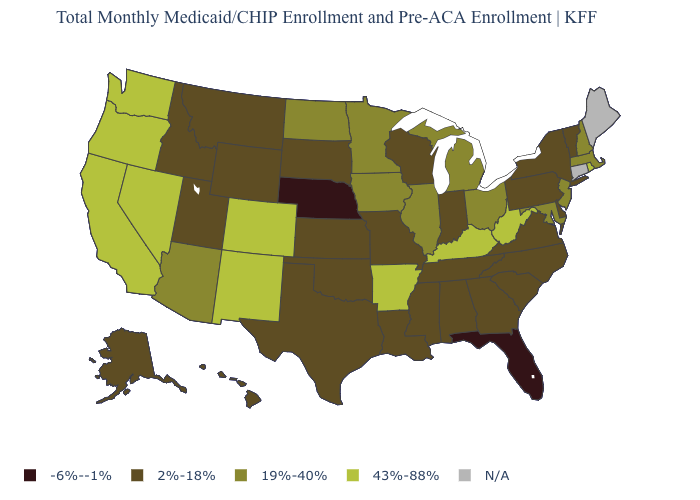Among the states that border Oregon , which have the highest value?
Quick response, please. California, Nevada, Washington. Among the states that border North Dakota , does Minnesota have the lowest value?
Keep it brief. No. Among the states that border Wyoming , which have the lowest value?
Concise answer only. Nebraska. What is the value of Vermont?
Give a very brief answer. 2%-18%. What is the value of Alaska?
Answer briefly. 2%-18%. How many symbols are there in the legend?
Concise answer only. 5. Among the states that border Alabama , does Tennessee have the highest value?
Short answer required. Yes. Among the states that border Virginia , does Kentucky have the lowest value?
Keep it brief. No. Does Vermont have the lowest value in the Northeast?
Give a very brief answer. Yes. Does Florida have the lowest value in the USA?
Be succinct. Yes. What is the highest value in the USA?
Concise answer only. 43%-88%. Which states hav the highest value in the MidWest?
Concise answer only. Illinois, Iowa, Michigan, Minnesota, North Dakota, Ohio. Does Iowa have the highest value in the MidWest?
Quick response, please. Yes. Among the states that border Oklahoma , which have the lowest value?
Quick response, please. Kansas, Missouri, Texas. What is the lowest value in states that border Nevada?
Answer briefly. 2%-18%. 